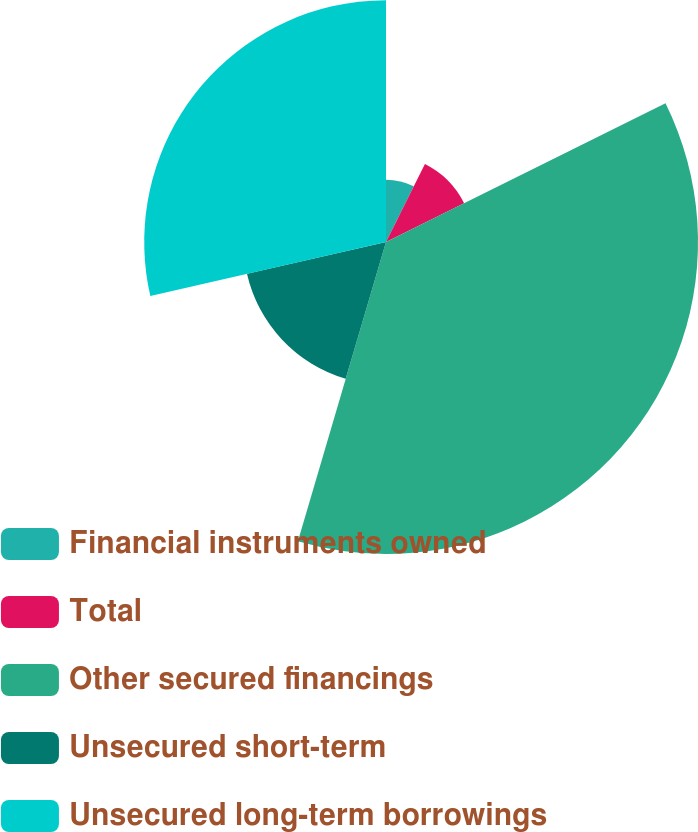Convert chart. <chart><loc_0><loc_0><loc_500><loc_500><pie_chart><fcel>Financial instruments owned<fcel>Total<fcel>Other secured financings<fcel>Unsecured short-term<fcel>Unsecured long-term borrowings<nl><fcel>7.36%<fcel>10.31%<fcel>36.88%<fcel>16.86%<fcel>28.58%<nl></chart> 